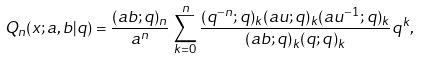<formula> <loc_0><loc_0><loc_500><loc_500>Q _ { n } ( x ; a , b | q ) = \frac { ( a b ; q ) _ { n } } { a ^ { n } } \, \sum _ { k = 0 } ^ { n } \frac { ( q ^ { - n } ; q ) _ { k } ( a u ; q ) _ { k } ( a u ^ { - 1 } ; q ) _ { k } } { ( a b ; q ) _ { k } ( q ; q ) _ { k } } q ^ { k } ,</formula> 